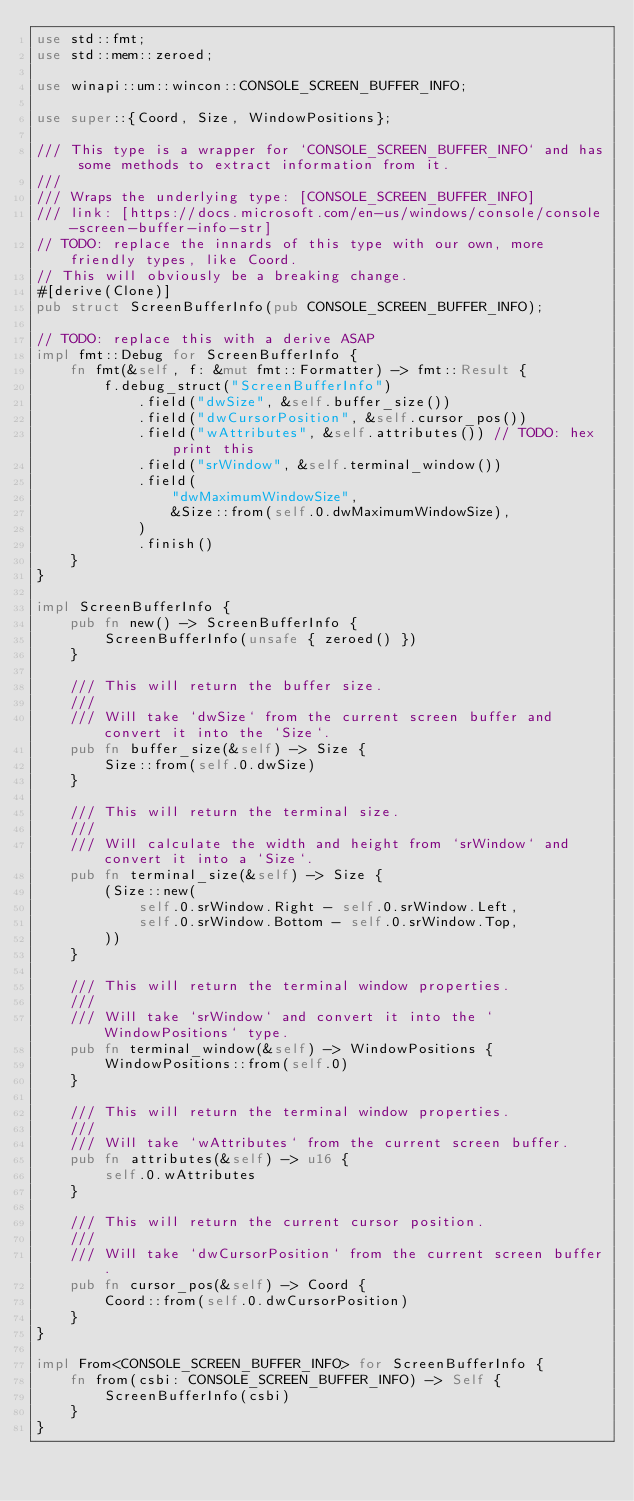<code> <loc_0><loc_0><loc_500><loc_500><_Rust_>use std::fmt;
use std::mem::zeroed;

use winapi::um::wincon::CONSOLE_SCREEN_BUFFER_INFO;

use super::{Coord, Size, WindowPositions};

/// This type is a wrapper for `CONSOLE_SCREEN_BUFFER_INFO` and has some methods to extract information from it.
///
/// Wraps the underlying type: [CONSOLE_SCREEN_BUFFER_INFO]
/// link: [https://docs.microsoft.com/en-us/windows/console/console-screen-buffer-info-str]
// TODO: replace the innards of this type with our own, more friendly types, like Coord.
// This will obviously be a breaking change.
#[derive(Clone)]
pub struct ScreenBufferInfo(pub CONSOLE_SCREEN_BUFFER_INFO);

// TODO: replace this with a derive ASAP
impl fmt::Debug for ScreenBufferInfo {
    fn fmt(&self, f: &mut fmt::Formatter) -> fmt::Result {
        f.debug_struct("ScreenBufferInfo")
            .field("dwSize", &self.buffer_size())
            .field("dwCursorPosition", &self.cursor_pos())
            .field("wAttributes", &self.attributes()) // TODO: hex print this
            .field("srWindow", &self.terminal_window())
            .field(
                "dwMaximumWindowSize",
                &Size::from(self.0.dwMaximumWindowSize),
            )
            .finish()
    }
}

impl ScreenBufferInfo {
    pub fn new() -> ScreenBufferInfo {
        ScreenBufferInfo(unsafe { zeroed() })
    }

    /// This will return the buffer size.
    ///
    /// Will take `dwSize` from the current screen buffer and convert it into the `Size`.
    pub fn buffer_size(&self) -> Size {
        Size::from(self.0.dwSize)
    }

    /// This will return the terminal size.
    ///
    /// Will calculate the width and height from `srWindow` and convert it into a `Size`.
    pub fn terminal_size(&self) -> Size {
        (Size::new(
            self.0.srWindow.Right - self.0.srWindow.Left,
            self.0.srWindow.Bottom - self.0.srWindow.Top,
        ))
    }

    /// This will return the terminal window properties.
    ///
    /// Will take `srWindow` and convert it into the `WindowPositions` type.
    pub fn terminal_window(&self) -> WindowPositions {
        WindowPositions::from(self.0)
    }

    /// This will return the terminal window properties.
    ///
    /// Will take `wAttributes` from the current screen buffer.
    pub fn attributes(&self) -> u16 {
        self.0.wAttributes
    }

    /// This will return the current cursor position.
    ///
    /// Will take `dwCursorPosition` from the current screen buffer.
    pub fn cursor_pos(&self) -> Coord {
        Coord::from(self.0.dwCursorPosition)
    }
}

impl From<CONSOLE_SCREEN_BUFFER_INFO> for ScreenBufferInfo {
    fn from(csbi: CONSOLE_SCREEN_BUFFER_INFO) -> Self {
        ScreenBufferInfo(csbi)
    }
}
</code> 